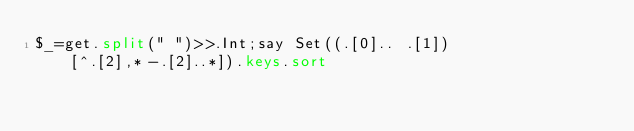<code> <loc_0><loc_0><loc_500><loc_500><_Perl_>$_=get.split(" ")>>.Int;say Set((.[0].. .[1])[^.[2],*-.[2]..*]).keys.sort</code> 